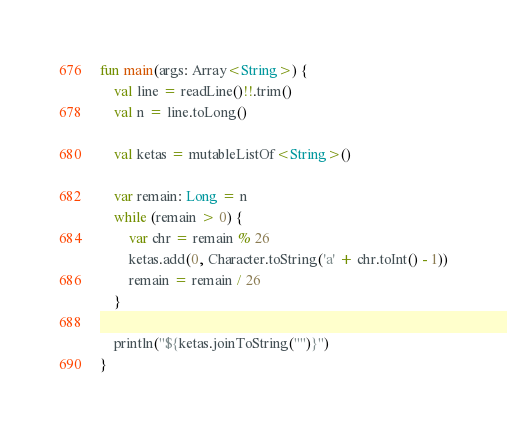<code> <loc_0><loc_0><loc_500><loc_500><_Kotlin_>fun main(args: Array<String>) {
    val line = readLine()!!.trim()
    val n = line.toLong()

    val ketas = mutableListOf<String>()

    var remain: Long = n
    while (remain > 0) {
        var chr = remain % 26
        ketas.add(0, Character.toString('a' + chr.toInt() - 1))
        remain = remain / 26
    }

    println("${ketas.joinToString("")}")
}</code> 